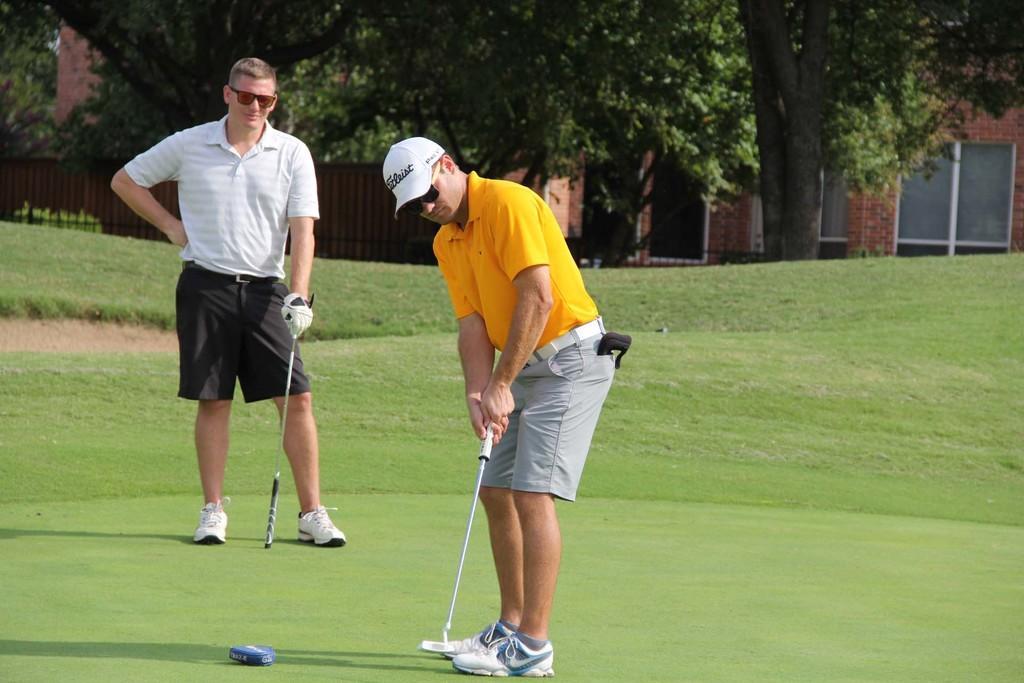Could you give a brief overview of what you see in this image? In the image there is a man with cap and goggles is standing on the ground and he is wearing shoes. Behind him there is a man with goggles is standing and holding a stick in the hand. In the background there is a fencing and also there are trees. Behind the trees there is a building with walls and glass windows. 